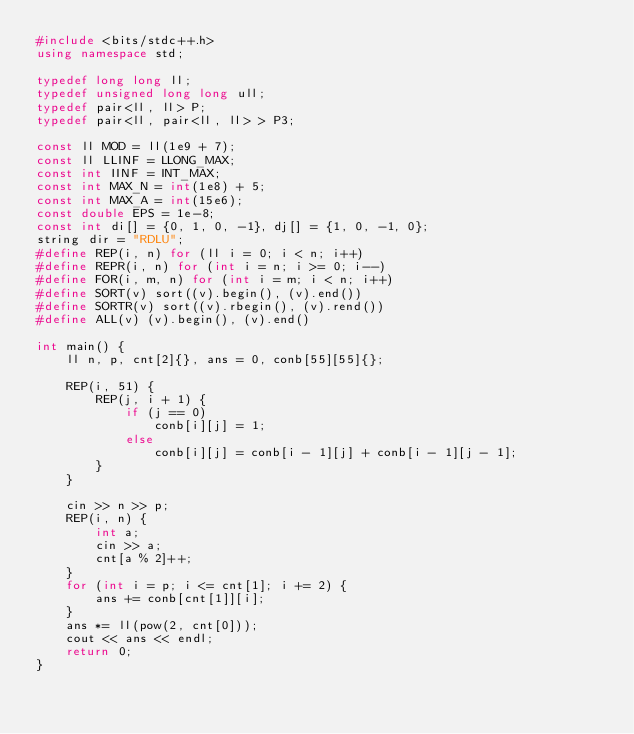<code> <loc_0><loc_0><loc_500><loc_500><_C++_>#include <bits/stdc++.h>
using namespace std;

typedef long long ll;
typedef unsigned long long ull;
typedef pair<ll, ll> P;
typedef pair<ll, pair<ll, ll> > P3;

const ll MOD = ll(1e9 + 7);
const ll LLINF = LLONG_MAX;
const int IINF = INT_MAX;
const int MAX_N = int(1e8) + 5;
const int MAX_A = int(15e6);
const double EPS = 1e-8;
const int di[] = {0, 1, 0, -1}, dj[] = {1, 0, -1, 0};
string dir = "RDLU";
#define REP(i, n) for (ll i = 0; i < n; i++)
#define REPR(i, n) for (int i = n; i >= 0; i--)
#define FOR(i, m, n) for (int i = m; i < n; i++)
#define SORT(v) sort((v).begin(), (v).end())
#define SORTR(v) sort((v).rbegin(), (v).rend())
#define ALL(v) (v).begin(), (v).end()

int main() {
    ll n, p, cnt[2]{}, ans = 0, conb[55][55]{};

    REP(i, 51) {
        REP(j, i + 1) {
            if (j == 0)
                conb[i][j] = 1;
            else
                conb[i][j] = conb[i - 1][j] + conb[i - 1][j - 1];
        }
    }

    cin >> n >> p;
    REP(i, n) {
        int a;
        cin >> a;
        cnt[a % 2]++;
    }
    for (int i = p; i <= cnt[1]; i += 2) {
        ans += conb[cnt[1]][i];
    }
    ans *= ll(pow(2, cnt[0]));
    cout << ans << endl;
    return 0;
}
</code> 